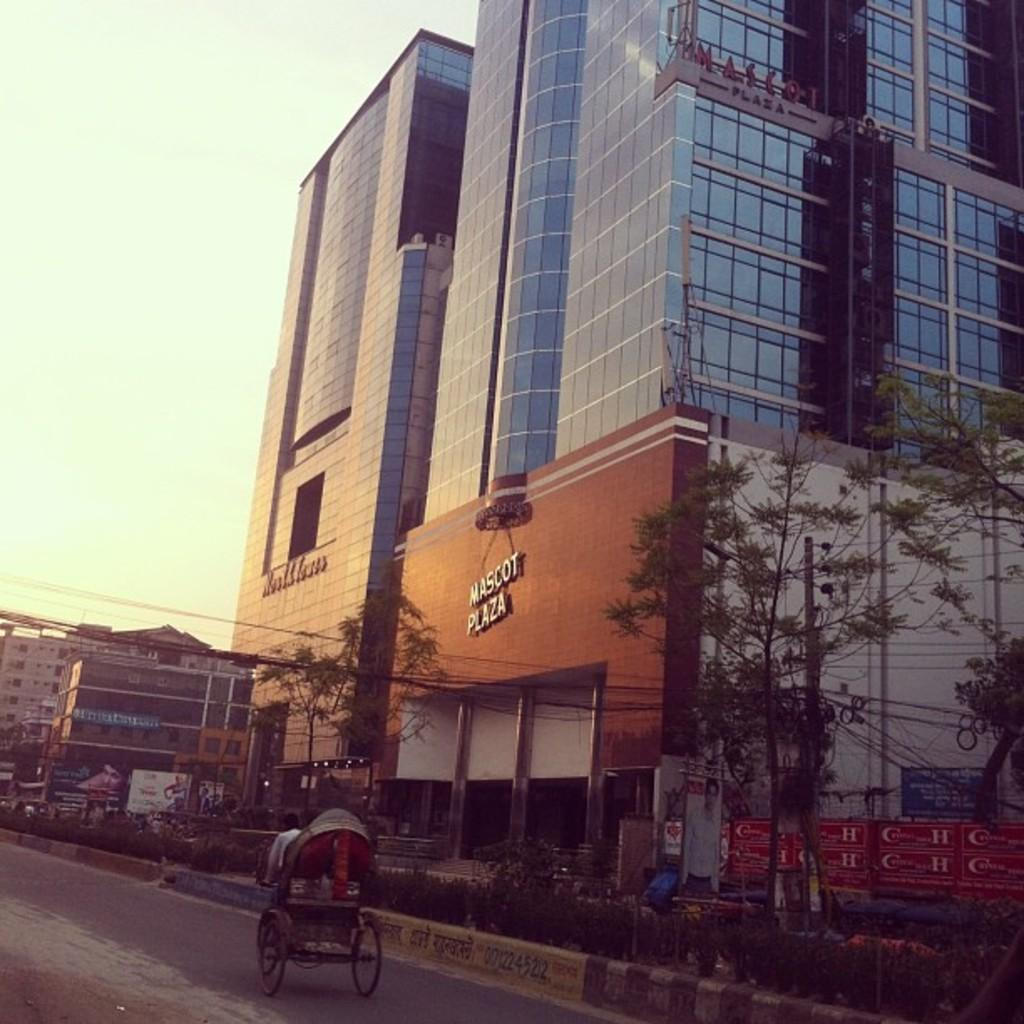What type of structures can be seen in the image? There are buildings in the image. What other natural elements are present in the image? There are trees and plants in the image. What objects can be seen on the ground in the image? There are boards and vehicles on the road in the image. What are the vertical structures in the image? There are poles in the image. What is visible at the top of the image? The sky is visible at the top of the image. How many sticks are being used to build the houses in the image? There are no sticks or houses present in the image. What type of scene is depicted in the image? The image does not depict a specific scene; it shows a combination of buildings, trees, boards, vehicles, poles, plants, and the sky. 